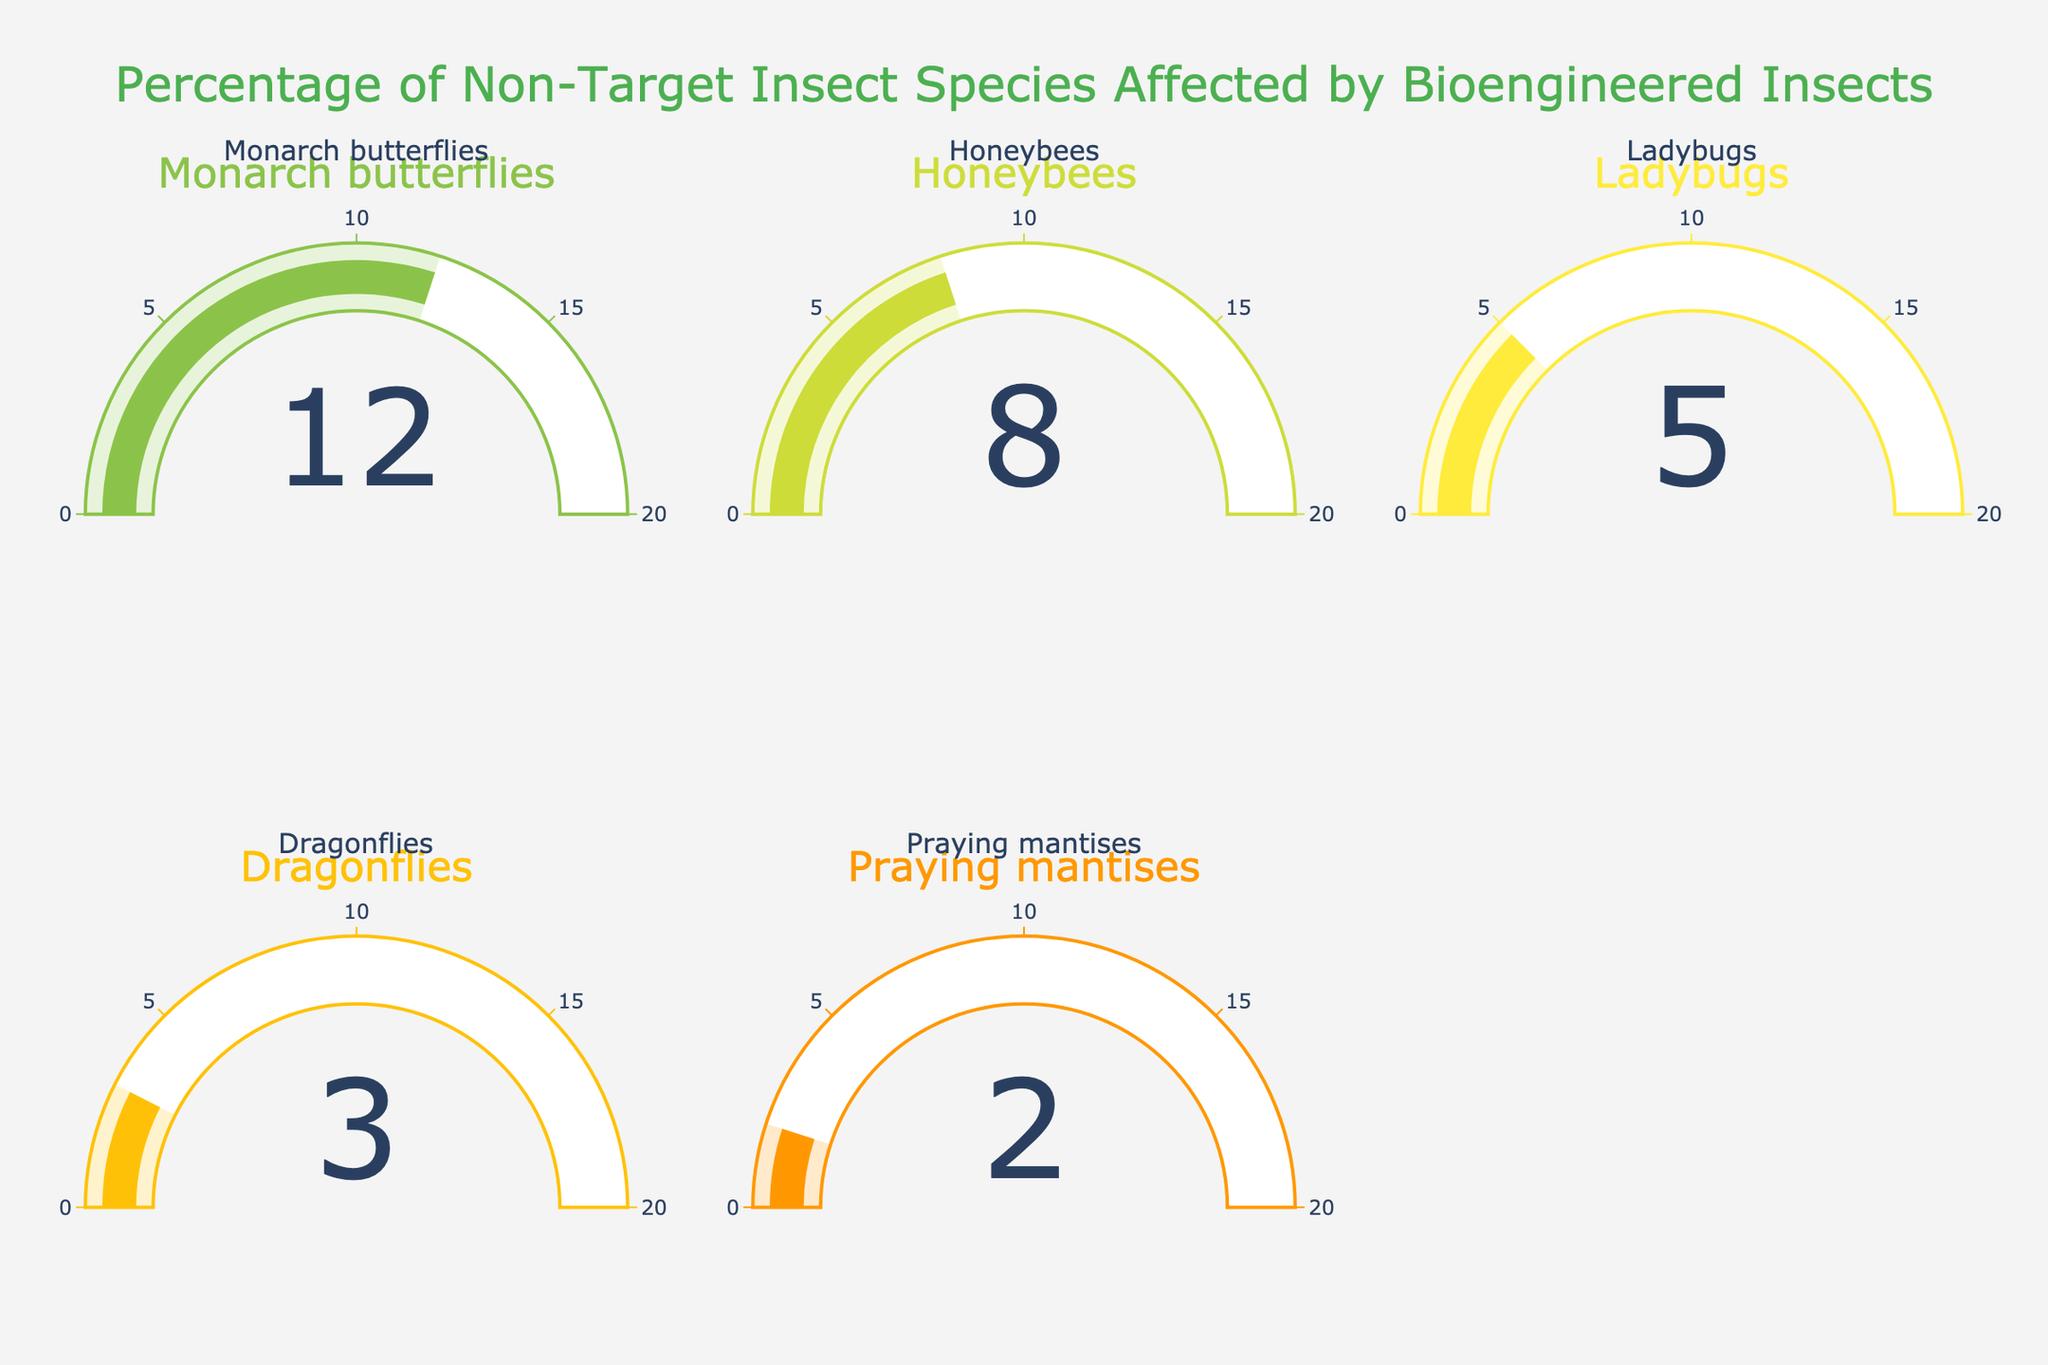What's the title of the figure? The title is clearly displayed at the top of the figure and reads "Percentage of Non-Target Insect Species Affected by Bioengineered Insects".
Answer: Percentage of Non-Target Insect Species Affected by Bioengineered Insects Which non-target insect species is affected the most by bioengineered insects? The gauge chart with the highest value is of Monarch butterflies, showing a percentage of 12.
Answer: Monarch butterflies Which species has the smallest percentage of non-target insects affected? The gauge chart for Praying mantises shows the smallest percentage, which is 2.
Answer: Praying mantises What is the total percentage of non-target insect species affected by bioengineered insects? To find the total percentage, sum all the values: 12 (Monarch butterflies) + 8 (Honeybees) + 5 (Ladybugs) + 3 (Dragonflies) + 2 (Praying mantises) = 30.
Answer: 30 How much higher is the percentage for Honeybees compared to Dragonflies? To determine this, subtract the percentage of Dragonflies from Honeybees: 8 (Honeybees) - 3 (Dragonflies) = 5.
Answer: 5 Which species has a percentage that is exactly double that of Praying mantises? The percentage for Praying mantises is 2. The species with double this percentage is Dragonflies, which have a percentage of 2 * 2 = 4.
Answer: Dragonflies What is the average percentage of non-target insect species affected? The average can be calculated by summing up all the percentages and dividing by the number of species: (12 + 8 + 5 + 3 + 2) / 5 = 6.
Answer: 6 If another non-target insect species were affected by 7%, would it have a higher or lower percentage than Ladybugs? The percentage for Ladybugs is 5%. Since 7% is greater than 5%, it would be higher.
Answer: Higher Which species has the closest percentage to the average affected percentage? The average percentage is 6, and the closest value among the species is the Honeybees' percentage, which is 8.
Answer: Honeybees 